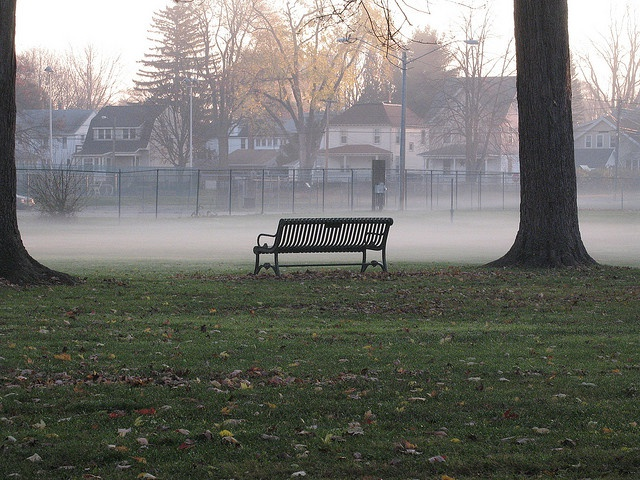Describe the objects in this image and their specific colors. I can see bench in black, darkgray, lightgray, and gray tones and car in black, gray, and darkgray tones in this image. 